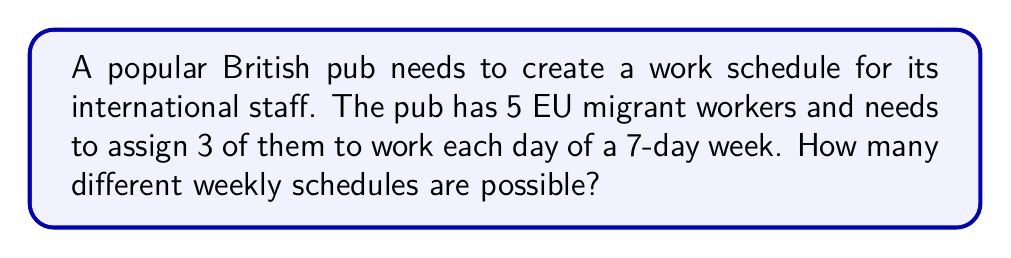Teach me how to tackle this problem. Let's approach this step-by-step:

1) First, we need to understand what we're calculating. For each day, we're selecting 3 workers out of 5. This is a combination problem.

2) The number of ways to select 3 workers out of 5 for a single day is given by the combination formula:

   $$C(5,3) = \frac{5!}{3!(5-3)!} = \frac{5!}{3!2!} = 10$$

3) Now, we need to make this selection for each of the 7 days of the week. Since the selection for each day is independent of the other days, we multiply the number of possibilities for each day.

4) Therefore, the total number of possible weekly schedules is:

   $$10 \times 10 \times 10 \times 10 \times 10 \times 10 \times 10 = 10^7$$

5) We can write this as:

   $$[C(5,3)]^7 = 10^7 = 10,000,000$$

This means there are 10 million different possible weekly schedules.
Answer: $10,000,000$ or $10^7$ possible weekly schedules 